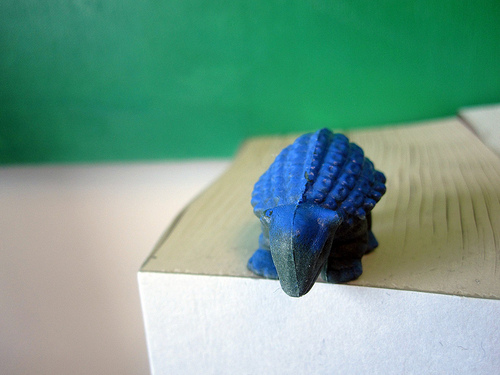<image>
Is there a dinosaur on the book? Yes. Looking at the image, I can see the dinosaur is positioned on top of the book, with the book providing support. 